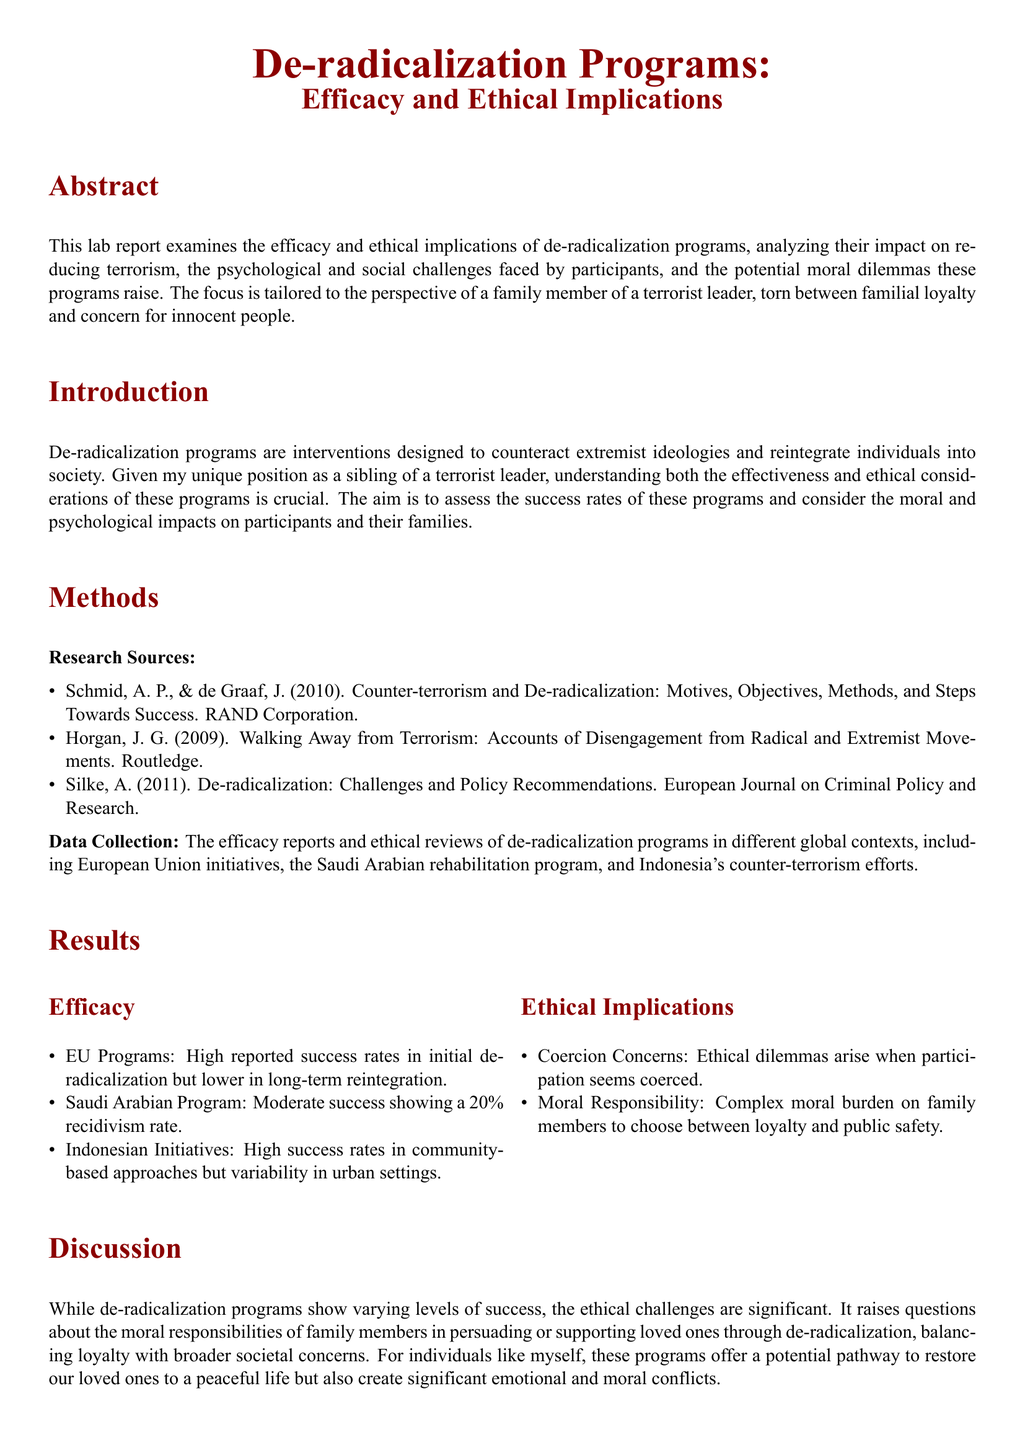What is the focus of the lab report? The lab report focuses on the efficacy and ethical implications of de-radicalization programs.
Answer: efficacy and ethical implications What percentage of recidivism does the Saudi Arabian program report? The report indicates that the Saudi Arabian program has a 20% recidivism rate.
Answer: 20% Which approach showed high success rates according to the Indonesian initiatives? The document states that community-based approaches in Indonesia showed high success rates.
Answer: community-based approaches What ethical concern is raised regarding participant coercion? The ethical dilemma discussed is the concern around coerced participation in de-radicalization programs.
Answer: Coercion Concerns What is the primary methodological source used in the research? The primary methodological source is from Schmid and de Graaf's work published by the RAND Corporation.
Answer: Schmid, A. P., & de Graaf, J How does the report characterize long-term reintegration success in EU programs? The report characterizes long-term reintegration success in EU programs as lower than initial de-radicalization success.
Answer: lower in long-term reintegration What does the report suggest for future research? The report suggests that future research should focus on improving the ethical frameworks of de-radicalization programs.
Answer: improving the ethical frameworks What type of member perspective is considered in this lab report? The perspective considered is from a family member of a terrorist leader.
Answer: family member of a terrorist leader What two elements do participants navigate according to the discussion? Participants navigate the elements of loyalty and societal welfare.
Answer: loyalty and societal welfare 